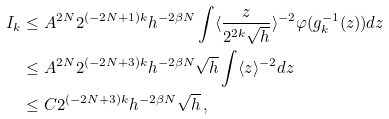<formula> <loc_0><loc_0><loc_500><loc_500>I _ { k } & \leq A ^ { 2 N } 2 ^ { ( - 2 N + 1 ) k } h ^ { - 2 \beta N } \int \langle \frac { z } { 2 ^ { 2 k } \sqrt { h } } \rangle ^ { - 2 } \varphi ( g _ { k } ^ { - 1 } ( z ) ) d z \\ & \leq A ^ { 2 N } 2 ^ { ( - 2 N + 3 ) k } h ^ { - 2 \beta N } \sqrt { h } \int \langle z \rangle ^ { - 2 } d z \\ & \leq C 2 ^ { ( - 2 N + 3 ) k } h ^ { - 2 \beta N } \sqrt { h } \, ,</formula> 